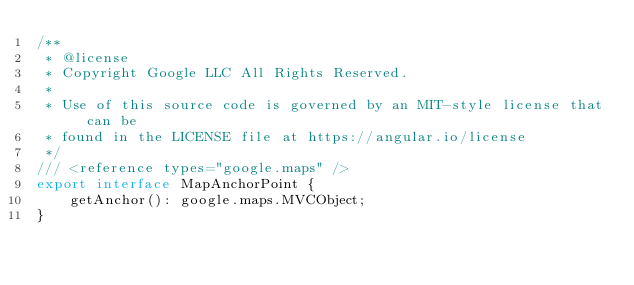<code> <loc_0><loc_0><loc_500><loc_500><_TypeScript_>/**
 * @license
 * Copyright Google LLC All Rights Reserved.
 *
 * Use of this source code is governed by an MIT-style license that can be
 * found in the LICENSE file at https://angular.io/license
 */
/// <reference types="google.maps" />
export interface MapAnchorPoint {
    getAnchor(): google.maps.MVCObject;
}
</code> 